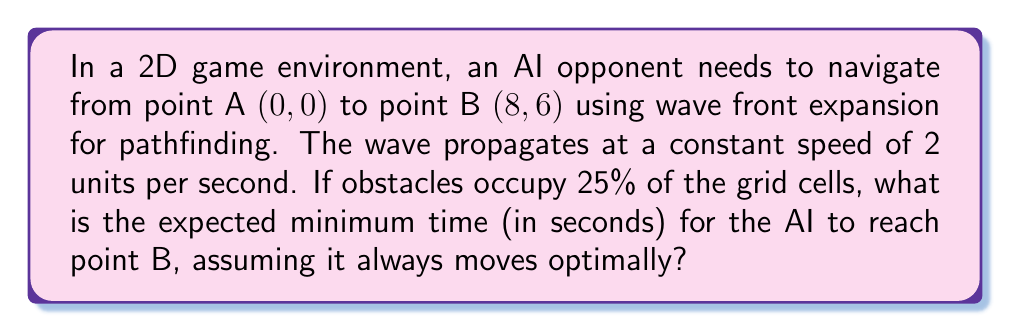What is the answer to this math problem? Let's approach this step-by-step:

1) First, we need to calculate the Manhattan distance between points A and B:
   $$d = |x_B - x_A| + |y_B - y_A| = |8 - 0| + |6 - 0| = 8 + 6 = 14$$

2) In an ideal scenario without obstacles, the time taken would be:
   $$t_{ideal} = \frac{d}{v} = \frac{14}{2} = 7 \text{ seconds}$$

3) However, we need to account for the obstacles. With 25% of cells occupied, the effective path length increases. We can model this increase using a factor:
   $$\text{Obstacle factor} = \frac{1}{1 - \text{obstacle percentage}} = \frac{1}{1 - 0.25} = \frac{4}{3}$$

4) The expected minimum time considering obstacles:
   $$t_{expected} = t_{ideal} \times \text{Obstacle factor} = 7 \times \frac{4}{3} = \frac{28}{3} \approx 9.33 \text{ seconds}$$

5) As we're dealing with discrete grid cells, we should round up to the nearest second:
   $$t_{final} = \lceil 9.33 \rceil = 10 \text{ seconds}$$

This approach ensures the AI opponent moves realistically through the game environment, providing a challenging yet fair pathfinding behavior for the professional gamer.
Answer: 10 seconds 